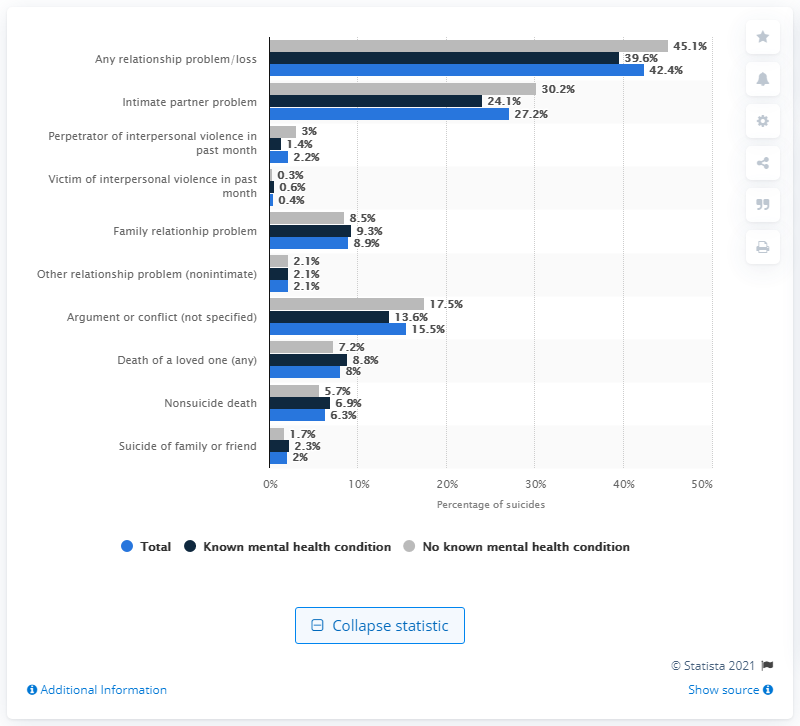Identify some key points in this picture. Approximately 30.2% of suicides among individuals with no known mental health condition were associated with intimate partner problems, according to the data. 